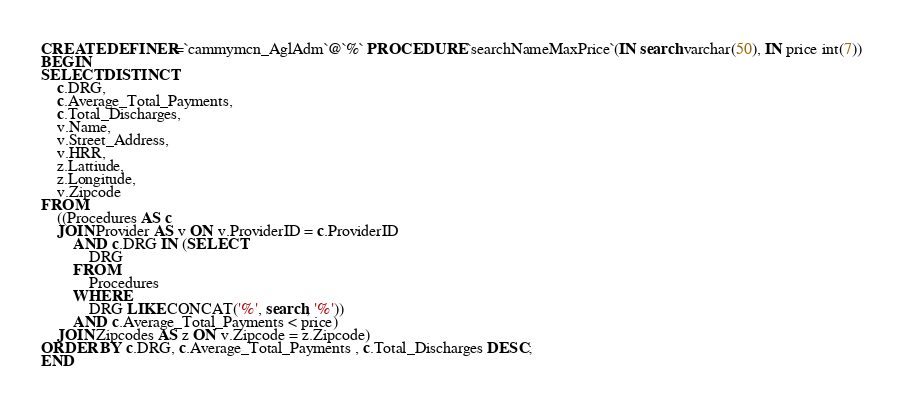<code> <loc_0><loc_0><loc_500><loc_500><_SQL_>CREATE DEFINER=`cammymcn_AglAdm`@`%` PROCEDURE `searchNameMaxPrice`(IN search varchar(50), IN price int(7))
BEGIN
SELECT DISTINCT
    c.DRG,
    c.Average_Total_Payments,
    c.Total_Discharges,
    v.Name,
    v.Street_Address,
    v.HRR,
    z.Lattiude,
    z.Longitude,
    v.Zipcode
FROM
    ((Procedures AS c
    JOIN Provider AS v ON v.ProviderID = c.ProviderID
        AND c.DRG IN (SELECT 
            DRG
        FROM
            Procedures
        WHERE
            DRG LIKE CONCAT('%', search, '%'))
		AND c.Average_Total_Payments < price)
    JOIN Zipcodes AS z ON v.Zipcode = z.Zipcode)
ORDER BY c.DRG, c.Average_Total_Payments , c.Total_Discharges DESC;
END</code> 